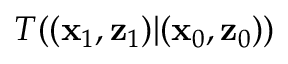<formula> <loc_0><loc_0><loc_500><loc_500>T ( ( x _ { 1 } , z _ { 1 } ) | ( x _ { 0 } , z _ { 0 } ) )</formula> 